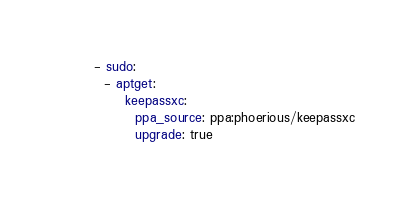<code> <loc_0><loc_0><loc_500><loc_500><_YAML_>- sudo:
  - aptget:
      keepassxc:
        ppa_source: ppa:phoerious/keepassxc
        upgrade: true

</code> 